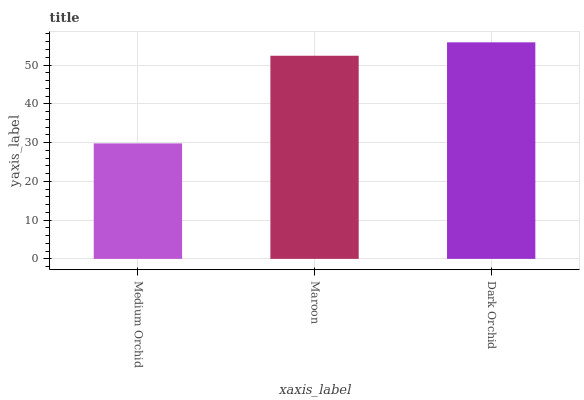Is Medium Orchid the minimum?
Answer yes or no. Yes. Is Dark Orchid the maximum?
Answer yes or no. Yes. Is Maroon the minimum?
Answer yes or no. No. Is Maroon the maximum?
Answer yes or no. No. Is Maroon greater than Medium Orchid?
Answer yes or no. Yes. Is Medium Orchid less than Maroon?
Answer yes or no. Yes. Is Medium Orchid greater than Maroon?
Answer yes or no. No. Is Maroon less than Medium Orchid?
Answer yes or no. No. Is Maroon the high median?
Answer yes or no. Yes. Is Maroon the low median?
Answer yes or no. Yes. Is Dark Orchid the high median?
Answer yes or no. No. Is Medium Orchid the low median?
Answer yes or no. No. 